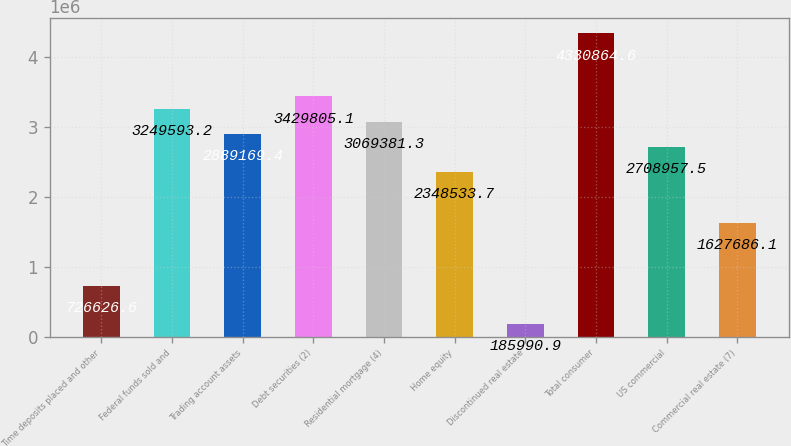<chart> <loc_0><loc_0><loc_500><loc_500><bar_chart><fcel>Time deposits placed and other<fcel>Federal funds sold and<fcel>Trading account assets<fcel>Debt securities (2)<fcel>Residential mortgage (4)<fcel>Home equity<fcel>Discontinued real estate<fcel>Total consumer<fcel>US commercial<fcel>Commercial real estate (7)<nl><fcel>726627<fcel>3.24959e+06<fcel>2.88917e+06<fcel>3.42981e+06<fcel>3.06938e+06<fcel>2.34853e+06<fcel>185991<fcel>4.33086e+06<fcel>2.70896e+06<fcel>1.62769e+06<nl></chart> 